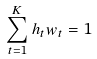<formula> <loc_0><loc_0><loc_500><loc_500>\sum _ { t = 1 } ^ { K } h _ { t } w _ { t } = 1</formula> 